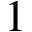Convert formula to latex. <formula><loc_0><loc_0><loc_500><loc_500>1</formula> 